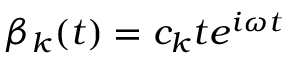Convert formula to latex. <formula><loc_0><loc_0><loc_500><loc_500>\beta _ { k } ( t ) = c _ { k } t e ^ { i \omega t }</formula> 